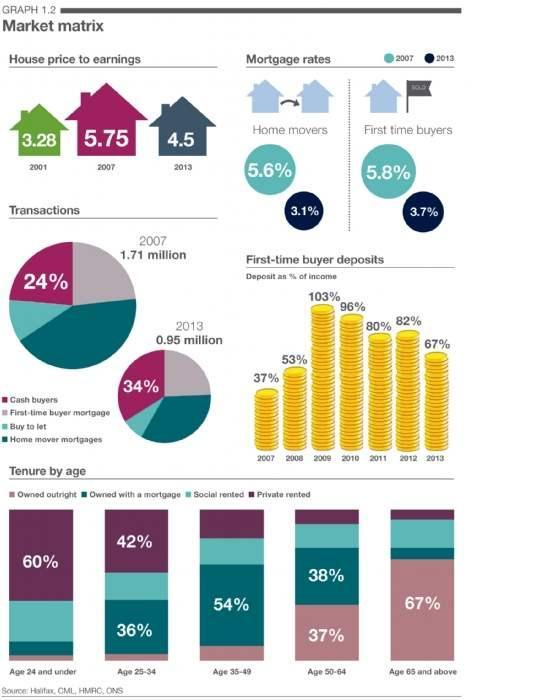What is the difference between amount deposited by first-time buyers in 2009 and 2010?
Answer the question with a short phrase. 7 What is the mortgage home loan rate for home movers in 2007? 5.6% What is the mortgage home loan rate for first home buyers in 2007? 5.8% What is the mortgage home loan rate for first home buyers in 2013? 3.7% In 2007 What percentage of home buyers were not given liquid cash during transactions? 76 What percentage of people in the age 35-49 have taken mortgage home loans for getting home? 54% What is the difference between Mortgage home loan rate for Home movers in 2007 and 2013? 2.5 How much the percentage of cash buyers for getting home got increased from 2007 to 2013? 10 What is the mortgage home loan rate for home movers in 2013? 3.1% What is the difference between Mortgage home loan rate for First time buyers in 2007 and 2013? 2.1 